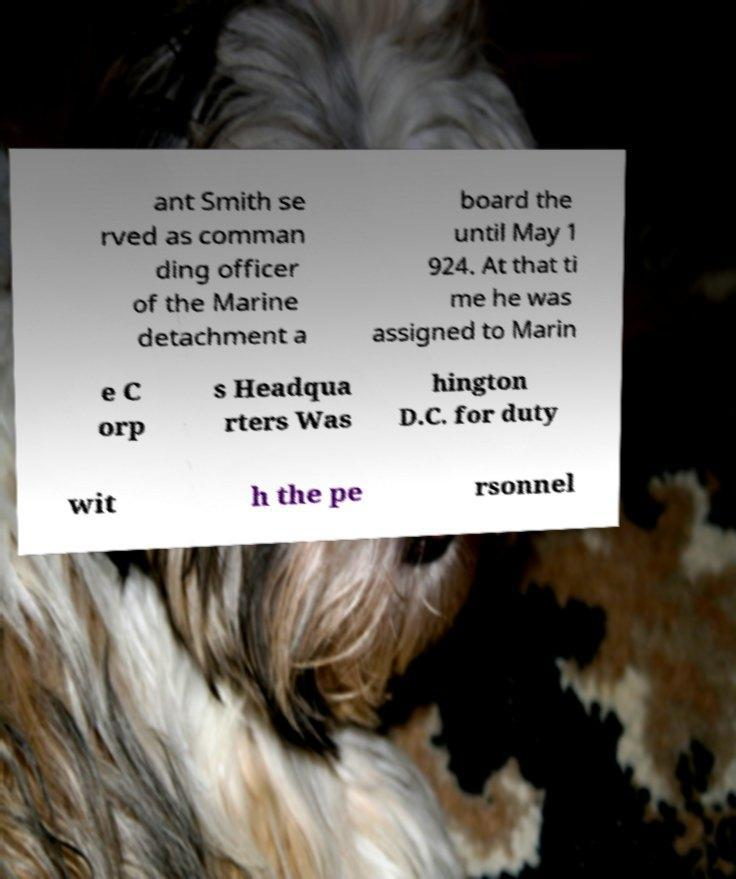Could you assist in decoding the text presented in this image and type it out clearly? ant Smith se rved as comman ding officer of the Marine detachment a board the until May 1 924. At that ti me he was assigned to Marin e C orp s Headqua rters Was hington D.C. for duty wit h the pe rsonnel 